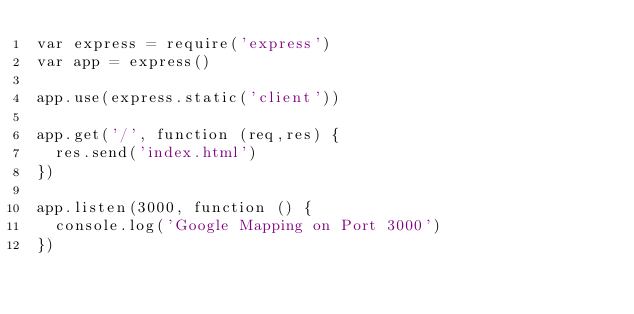Convert code to text. <code><loc_0><loc_0><loc_500><loc_500><_JavaScript_>var express = require('express')
var app = express()

app.use(express.static('client'))

app.get('/', function (req,res) {
  res.send('index.html')
})

app.listen(3000, function () {
  console.log('Google Mapping on Port 3000')
})
</code> 